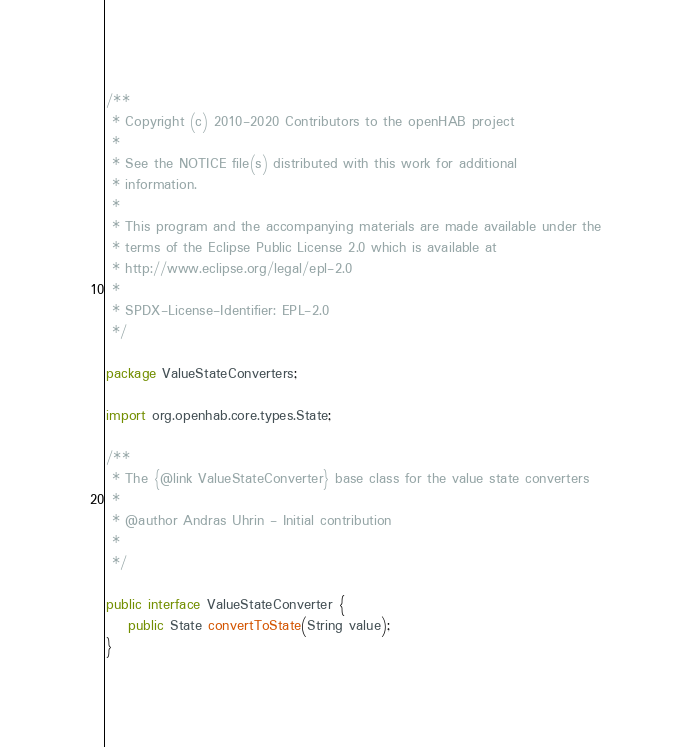<code> <loc_0><loc_0><loc_500><loc_500><_Java_>/**
 * Copyright (c) 2010-2020 Contributors to the openHAB project
 *
 * See the NOTICE file(s) distributed with this work for additional
 * information.
 *
 * This program and the accompanying materials are made available under the
 * terms of the Eclipse Public License 2.0 which is available at
 * http://www.eclipse.org/legal/epl-2.0
 *
 * SPDX-License-Identifier: EPL-2.0
 */

package ValueStateConverters;

import org.openhab.core.types.State;

/**
 * The {@link ValueStateConverter} base class for the value state converters
 *
 * @author Andras Uhrin - Initial contribution
 *
 */

public interface ValueStateConverter {
    public State convertToState(String value);
}
</code> 